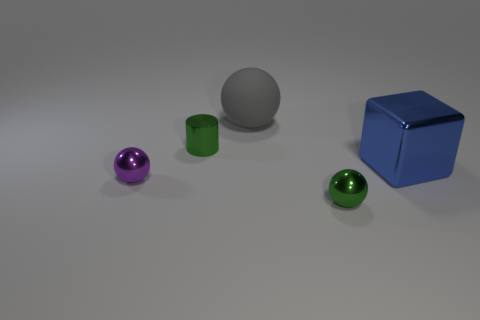What size is the green object on the right side of the thing behind the small green object behind the blue metal cube?
Make the answer very short. Small. There is a sphere behind the large metal block; is it the same color as the metallic cylinder?
Your response must be concise. No. There is another shiny object that is the same shape as the tiny purple thing; what size is it?
Your answer should be very brief. Small. What number of objects are either green metallic objects in front of the cylinder or tiny shiny balls left of the big gray rubber thing?
Give a very brief answer. 2. There is a small green thing behind the tiny green thing that is in front of the purple metallic object; what shape is it?
Ensure brevity in your answer.  Cylinder. Is there anything else that has the same color as the big metallic cube?
Your answer should be very brief. No. Is there anything else that has the same size as the gray ball?
Your answer should be very brief. Yes. What number of objects are small metallic cylinders or big rubber spheres?
Your response must be concise. 2. Are there any green matte objects of the same size as the matte ball?
Your answer should be very brief. No. There is a blue shiny object; what shape is it?
Your answer should be compact. Cube. 